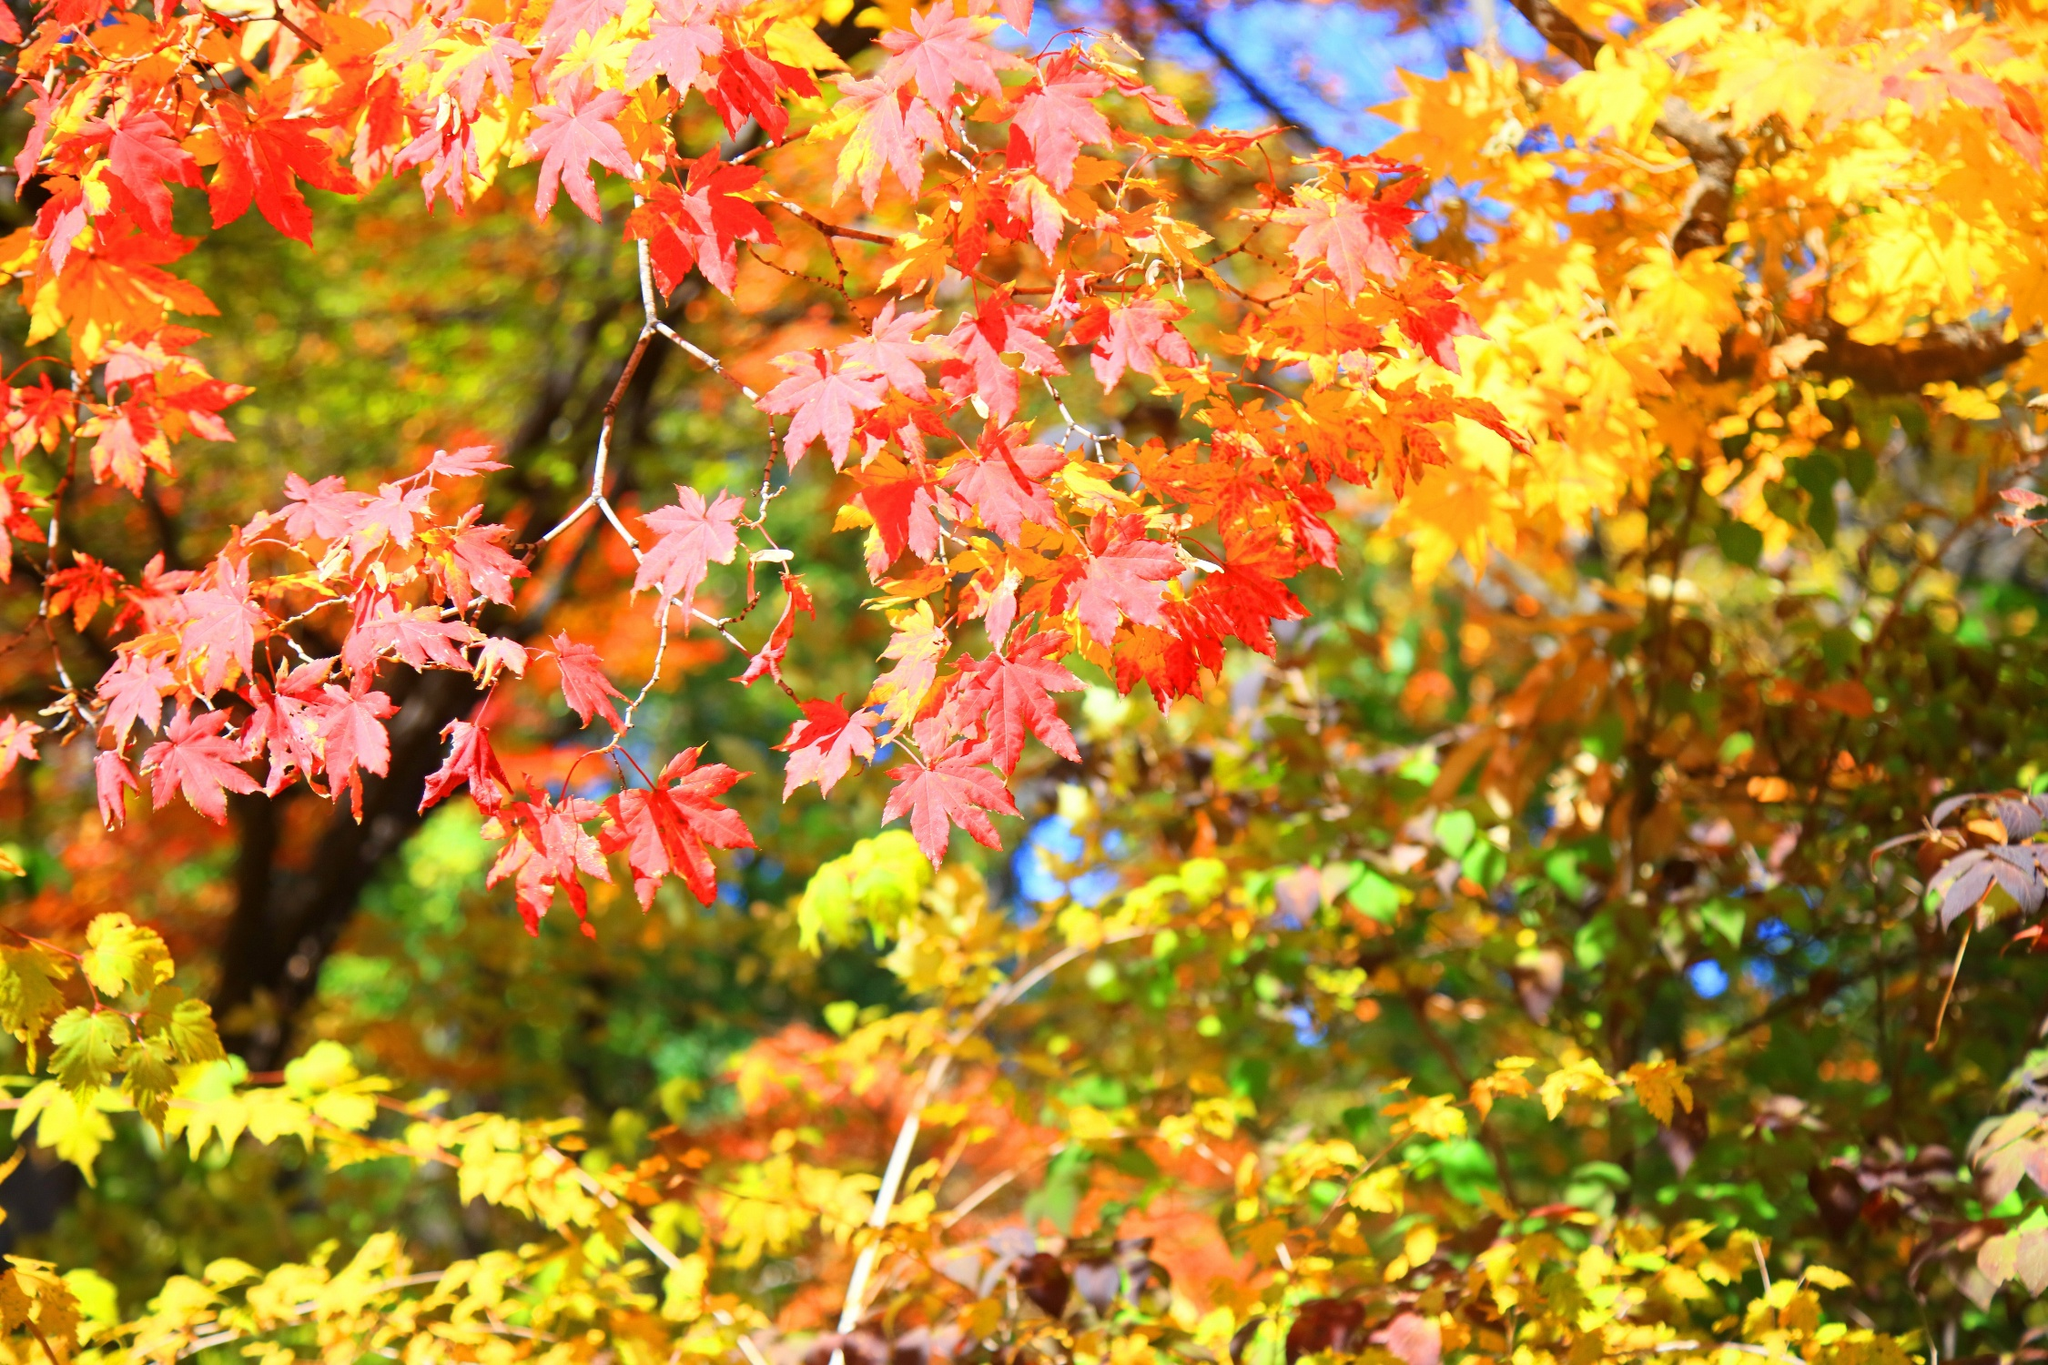Imagine this is the central tree in an ancient forest. What legends might surround it? The central tree in this ancient forest is shrouded in countless legends passed down through generations. One tale speaks of it as the 'Tree of Seasons,' believed to have been planted by the gods themselves at the dawn of time. It's said that each leaf represents a soul, and as they change colors, they symbolize the circle of life: birth, growth, death, and rebirth. Another legend tells of the forest's guardian, a mythical creature who sleeps within the tree’s roots, awakening only when the forest is in grave danger. Villagers from distant lands come to this tree to seek its blessings, hoping that the spirit of the tree will grant them prosperity and protection. The whispers of the wind through its branches are thought to carry messages from the past, offering wisdom to those who listen closely. What rituals might people perform around this tree? People might gather around this sacred tree at various times of the year to perform rituals that honor the cycles of nature and seek blessings. During the autumn equinox, they might hold a festival where they light candles and make offerings of harvested crops, thanking the tree for its bounty. A solemn ceremony might take place at twilight, where participants tie ribbons of red, orange, and yellow around the tree's branches, symbolizing their hopes and prayers. In the spring, a renewal ritual could involve planting new seedlings around the tree, each person speaking a wish for the future as they bury the seeds. Music, dance, and storytelling would likely accompany these rituals, as communities come together to celebrate their connection to this sacred, ancient tree. 